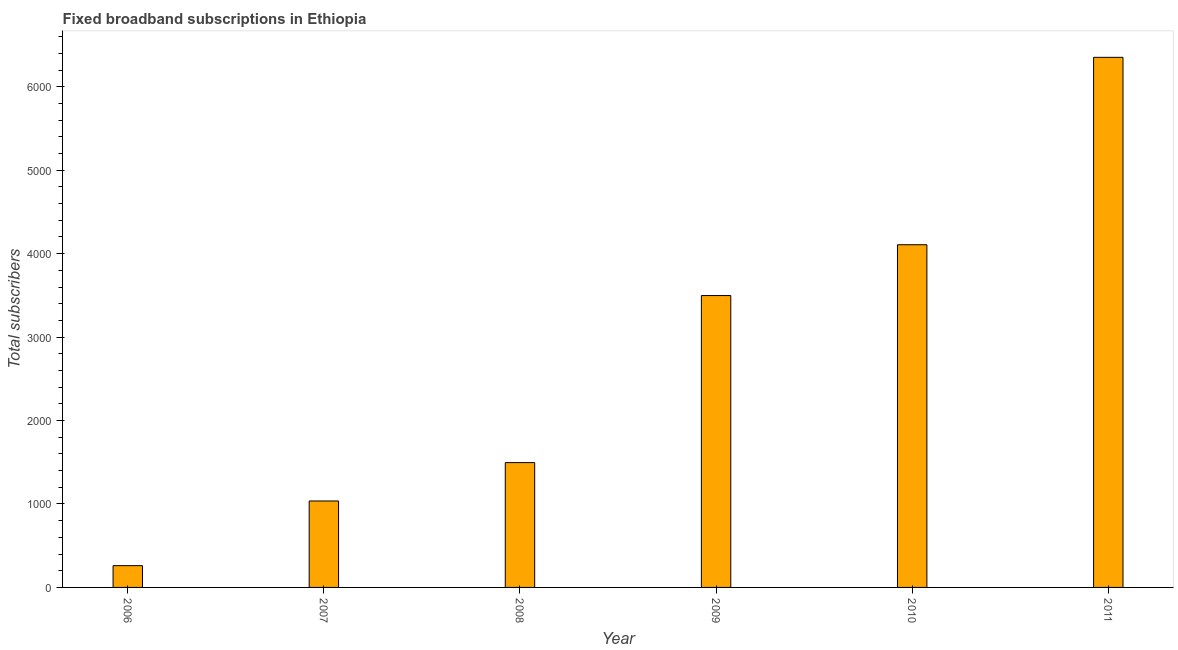Does the graph contain grids?
Make the answer very short. No. What is the title of the graph?
Keep it short and to the point. Fixed broadband subscriptions in Ethiopia. What is the label or title of the Y-axis?
Your response must be concise. Total subscribers. What is the total number of fixed broadband subscriptions in 2007?
Keep it short and to the point. 1036. Across all years, what is the maximum total number of fixed broadband subscriptions?
Ensure brevity in your answer.  6353. Across all years, what is the minimum total number of fixed broadband subscriptions?
Your response must be concise. 261. In which year was the total number of fixed broadband subscriptions maximum?
Your answer should be compact. 2011. In which year was the total number of fixed broadband subscriptions minimum?
Give a very brief answer. 2006. What is the sum of the total number of fixed broadband subscriptions?
Give a very brief answer. 1.68e+04. What is the difference between the total number of fixed broadband subscriptions in 2009 and 2010?
Give a very brief answer. -609. What is the average total number of fixed broadband subscriptions per year?
Ensure brevity in your answer.  2791. What is the median total number of fixed broadband subscriptions?
Make the answer very short. 2497. In how many years, is the total number of fixed broadband subscriptions greater than 1400 ?
Give a very brief answer. 4. What is the ratio of the total number of fixed broadband subscriptions in 2008 to that in 2010?
Offer a very short reply. 0.36. What is the difference between the highest and the second highest total number of fixed broadband subscriptions?
Provide a succinct answer. 2246. What is the difference between the highest and the lowest total number of fixed broadband subscriptions?
Ensure brevity in your answer.  6092. In how many years, is the total number of fixed broadband subscriptions greater than the average total number of fixed broadband subscriptions taken over all years?
Give a very brief answer. 3. How many bars are there?
Your answer should be compact. 6. Are all the bars in the graph horizontal?
Offer a terse response. No. How many years are there in the graph?
Your answer should be very brief. 6. What is the difference between two consecutive major ticks on the Y-axis?
Your response must be concise. 1000. Are the values on the major ticks of Y-axis written in scientific E-notation?
Your answer should be compact. No. What is the Total subscribers in 2006?
Provide a short and direct response. 261. What is the Total subscribers in 2007?
Your answer should be compact. 1036. What is the Total subscribers in 2008?
Provide a succinct answer. 1496. What is the Total subscribers in 2009?
Make the answer very short. 3498. What is the Total subscribers in 2010?
Your response must be concise. 4107. What is the Total subscribers of 2011?
Make the answer very short. 6353. What is the difference between the Total subscribers in 2006 and 2007?
Your answer should be very brief. -775. What is the difference between the Total subscribers in 2006 and 2008?
Offer a terse response. -1235. What is the difference between the Total subscribers in 2006 and 2009?
Keep it short and to the point. -3237. What is the difference between the Total subscribers in 2006 and 2010?
Offer a terse response. -3846. What is the difference between the Total subscribers in 2006 and 2011?
Your answer should be very brief. -6092. What is the difference between the Total subscribers in 2007 and 2008?
Provide a succinct answer. -460. What is the difference between the Total subscribers in 2007 and 2009?
Your response must be concise. -2462. What is the difference between the Total subscribers in 2007 and 2010?
Make the answer very short. -3071. What is the difference between the Total subscribers in 2007 and 2011?
Keep it short and to the point. -5317. What is the difference between the Total subscribers in 2008 and 2009?
Your answer should be very brief. -2002. What is the difference between the Total subscribers in 2008 and 2010?
Ensure brevity in your answer.  -2611. What is the difference between the Total subscribers in 2008 and 2011?
Provide a succinct answer. -4857. What is the difference between the Total subscribers in 2009 and 2010?
Your answer should be very brief. -609. What is the difference between the Total subscribers in 2009 and 2011?
Provide a succinct answer. -2855. What is the difference between the Total subscribers in 2010 and 2011?
Keep it short and to the point. -2246. What is the ratio of the Total subscribers in 2006 to that in 2007?
Your answer should be compact. 0.25. What is the ratio of the Total subscribers in 2006 to that in 2008?
Keep it short and to the point. 0.17. What is the ratio of the Total subscribers in 2006 to that in 2009?
Keep it short and to the point. 0.07. What is the ratio of the Total subscribers in 2006 to that in 2010?
Offer a terse response. 0.06. What is the ratio of the Total subscribers in 2006 to that in 2011?
Your answer should be very brief. 0.04. What is the ratio of the Total subscribers in 2007 to that in 2008?
Your answer should be very brief. 0.69. What is the ratio of the Total subscribers in 2007 to that in 2009?
Offer a terse response. 0.3. What is the ratio of the Total subscribers in 2007 to that in 2010?
Your answer should be compact. 0.25. What is the ratio of the Total subscribers in 2007 to that in 2011?
Make the answer very short. 0.16. What is the ratio of the Total subscribers in 2008 to that in 2009?
Provide a short and direct response. 0.43. What is the ratio of the Total subscribers in 2008 to that in 2010?
Keep it short and to the point. 0.36. What is the ratio of the Total subscribers in 2008 to that in 2011?
Ensure brevity in your answer.  0.23. What is the ratio of the Total subscribers in 2009 to that in 2010?
Keep it short and to the point. 0.85. What is the ratio of the Total subscribers in 2009 to that in 2011?
Your response must be concise. 0.55. What is the ratio of the Total subscribers in 2010 to that in 2011?
Your answer should be very brief. 0.65. 